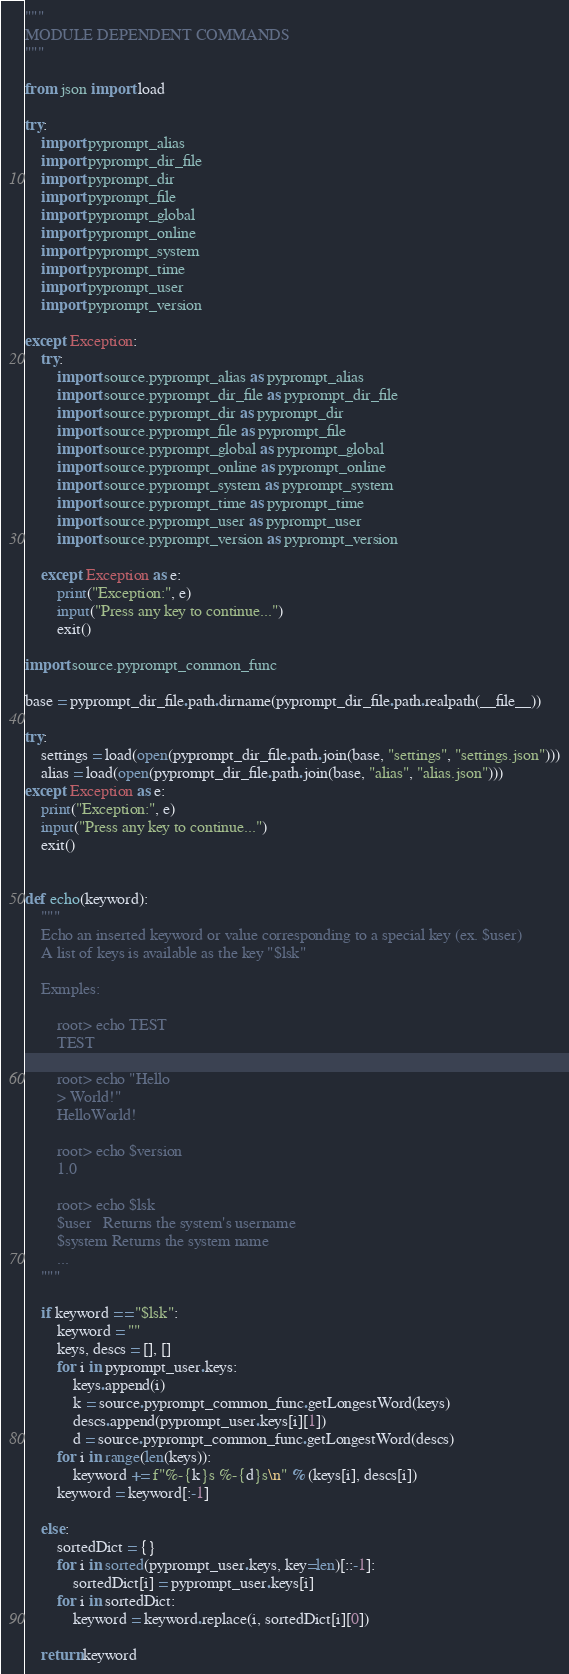<code> <loc_0><loc_0><loc_500><loc_500><_Python_>"""
MODULE DEPENDENT COMMANDS
"""

from json import load

try:
	import pyprompt_alias
	import pyprompt_dir_file
	import pyprompt_dir
	import pyprompt_file
	import pyprompt_global
	import pyprompt_online
	import pyprompt_system
	import pyprompt_time
	import pyprompt_user
	import pyprompt_version

except Exception:
	try:
		import source.pyprompt_alias as pyprompt_alias
		import source.pyprompt_dir_file as pyprompt_dir_file
		import source.pyprompt_dir as pyprompt_dir
		import source.pyprompt_file as pyprompt_file
		import source.pyprompt_global as pyprompt_global
		import source.pyprompt_online as pyprompt_online
		import source.pyprompt_system as pyprompt_system
		import source.pyprompt_time as pyprompt_time
		import source.pyprompt_user as pyprompt_user
		import source.pyprompt_version as pyprompt_version

	except Exception as e:
		print("Exception:", e)
		input("Press any key to continue...")
		exit()

import source.pyprompt_common_func

base = pyprompt_dir_file.path.dirname(pyprompt_dir_file.path.realpath(__file__))

try:
	settings = load(open(pyprompt_dir_file.path.join(base, "settings", "settings.json")))
	alias = load(open(pyprompt_dir_file.path.join(base, "alias", "alias.json")))
except Exception as e:
	print("Exception:", e)
	input("Press any key to continue...")
	exit()


def echo(keyword):
	"""
	Echo an inserted keyword or value corresponding to a special key (ex. $user)
	A list of keys is available as the key "$lsk"

	Exmples:

		root> echo TEST
		TEST

		root> echo "Hello
		> World!"
		HelloWorld!

		root> echo $version
		1.0

		root> echo $lsk
		$user   Returns the system's username
		$system Returns the system name
		...
	"""

	if keyword == "$lsk":
		keyword = ""
		keys, descs = [], []
		for i in pyprompt_user.keys:
			keys.append(i)
			k = source.pyprompt_common_func.getLongestWord(keys)
			descs.append(pyprompt_user.keys[i][1])
			d = source.pyprompt_common_func.getLongestWord(descs)
		for i in range(len(keys)):
			keyword += f"%-{k}s %-{d}s\n" % (keys[i], descs[i])
		keyword = keyword[:-1]

	else:
		sortedDict = {}
		for i in sorted(pyprompt_user.keys, key=len)[::-1]:
			sortedDict[i] = pyprompt_user.keys[i]
		for i in sortedDict:
			keyword = keyword.replace(i, sortedDict[i][0])

	return keyword
</code> 